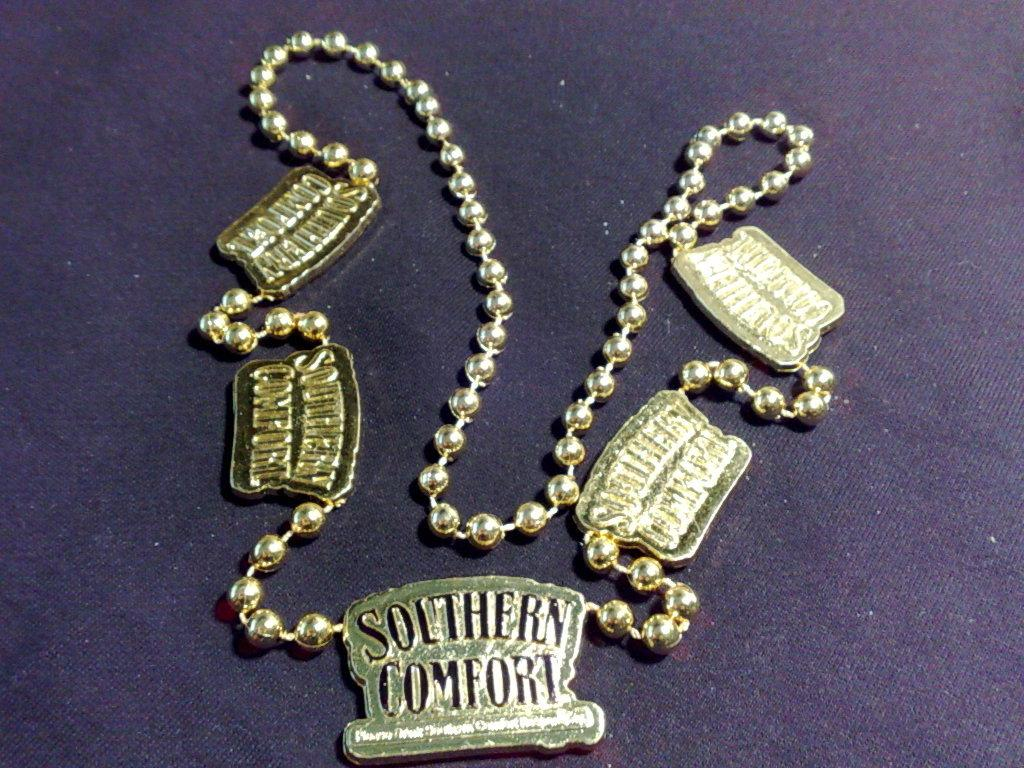<image>
Summarize the visual content of the image. A gold colored necklace has several charms that say Southern Comfort on it. 